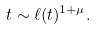Convert formula to latex. <formula><loc_0><loc_0><loc_500><loc_500>t \sim \ell ( t ) ^ { 1 + \mu } .</formula> 